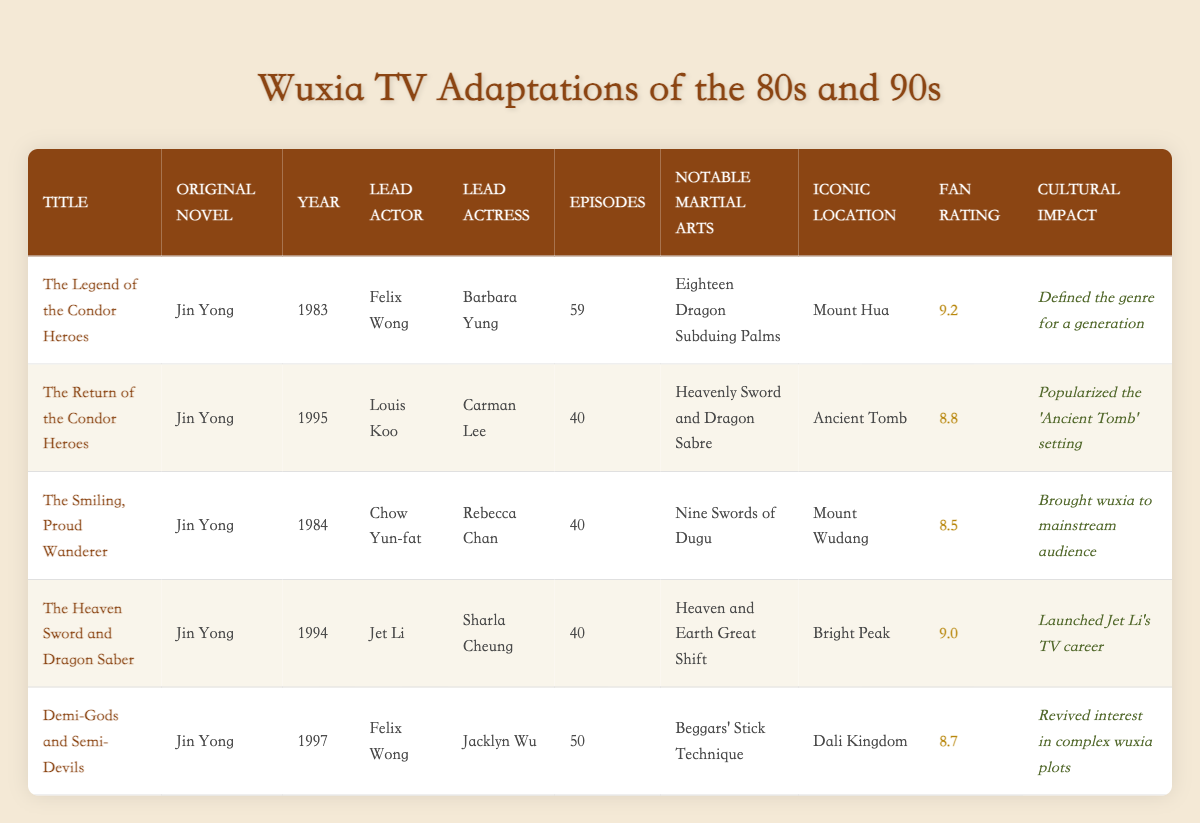What is the lead actor in "The Return of the Condor Heroes"? The table shows that the lead actor for "The Return of the Condor Heroes" is Louis Koo, as listed in the "Lead Actor" column for that specific title.
Answer: Louis Koo Which adaptation has the highest fan rating? By reviewing the "Fan Rating" column, it’s clear that "The Legend of the Condor Heroes" has the highest rating of 9.2 out of 10.
Answer: 9.2 How many episodes did "The Smiling, Proud Wanderer" have? The table indicates that "The Smiling, Proud Wanderer" consists of 40 episodes, as noted in the "Episodes" column for that title.
Answer: 40 What is the average fan rating of all adaptations listed? To find the average fan rating, sum the individual ratings: 9.2 + 8.8 + 8.5 + 9.0 + 8.7 = 43.2. There are 5 adaptations, so divide the sum by 5: 43.2 / 5 = 8.64.
Answer: 8.64 Did Felix Wong star in both "The Legend of the Condor Heroes" and "Demi-Gods and Semi-Devils"? Yes, according to the "Lead Actor" column, Felix Wong is listed as the lead actor for both "The Legend of the Condor Heroes" (1983) and "Demi-Gods and Semi-Devils" (1997).
Answer: Yes Which adaptation features the "Heavenly Sword and Dragon Sabre" martial arts? The entry for "The Return of the Condor Heroes" in the "Notable Martial Arts" column specifies that it features "Heavenly Sword and Dragon Sabre."
Answer: The Return of the Condor Heroes Which adaptation had a cultural impact of reviving interest in complex wuxia plots? The table notes that "Demi-Gods and Semi-Devils" had a cultural impact that revived interest in complex wuxia plots, as indicated in the "Cultural Impact" column.
Answer: Demi-Gods and Semi-Devils Which two adaptations were released in the 1990s? The adaptations from the 1990s are "The Return of the Condor Heroes" (1995) and "The Heaven Sword and Dragon Saber" (1994), as determined by looking at the "Year" column for each title.
Answer: The Return of the Condor Heroes and The Heaven Sword and Dragon Saber What is the notable martial art featured in "The Heaven Sword and Dragon Saber"? Referring to the "Notable Martial Arts" column for "The Heaven Sword and Dragon Saber," it states that the notable martial art is "Heaven and Earth Great Shift."
Answer: Heaven and Earth Great Shift 